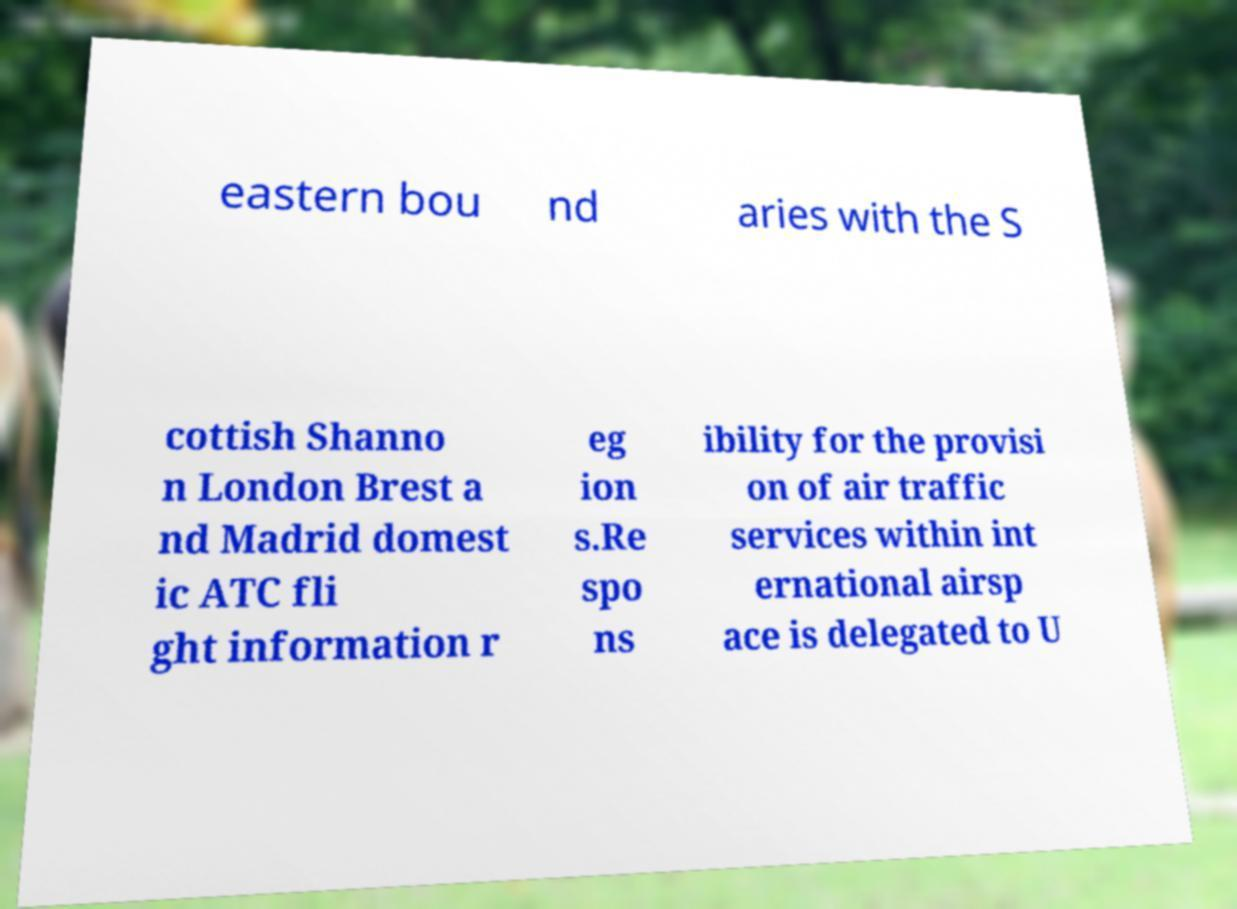I need the written content from this picture converted into text. Can you do that? eastern bou nd aries with the S cottish Shanno n London Brest a nd Madrid domest ic ATC fli ght information r eg ion s.Re spo ns ibility for the provisi on of air traffic services within int ernational airsp ace is delegated to U 